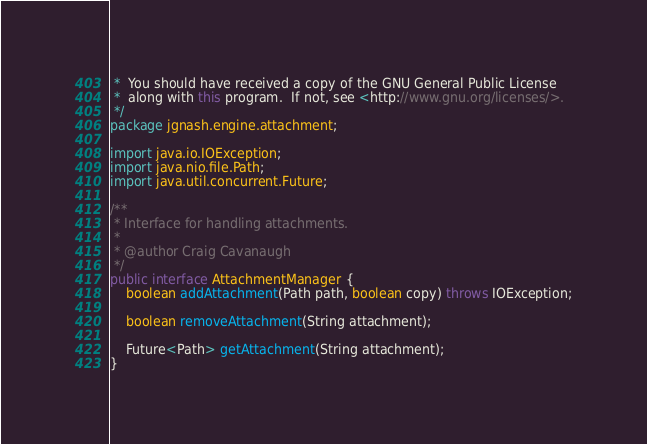<code> <loc_0><loc_0><loc_500><loc_500><_Java_> *  You should have received a copy of the GNU General Public License
 *  along with this program.  If not, see <http://www.gnu.org/licenses/>.
 */
package jgnash.engine.attachment;

import java.io.IOException;
import java.nio.file.Path;
import java.util.concurrent.Future;

/**
 * Interface for handling attachments.
 *
 * @author Craig Cavanaugh
 */
public interface AttachmentManager {
    boolean addAttachment(Path path, boolean copy) throws IOException;

    boolean removeAttachment(String attachment);

    Future<Path> getAttachment(String attachment);
}
</code> 